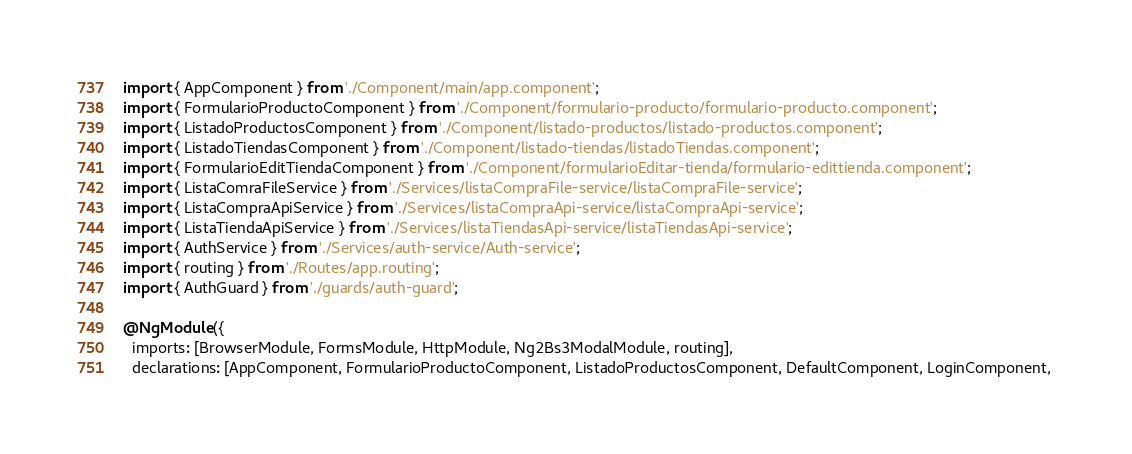Convert code to text. <code><loc_0><loc_0><loc_500><loc_500><_TypeScript_>import { AppComponent } from './Component/main/app.component';
import { FormularioProductoComponent } from './Component/formulario-producto/formulario-producto.component';
import { ListadoProductosComponent } from './Component/listado-productos/listado-productos.component';
import { ListadoTiendasComponent } from './Component/listado-tiendas/listadoTiendas.component';
import { FormularioEditTiendaComponent } from './Component/formularioEditar-tienda/formulario-edittienda.component';
import { ListaComraFileService } from './Services/listaCompraFile-service/listaCompraFile-service';
import { ListaCompraApiService } from './Services/listaCompraApi-service/listaCompraApi-service';
import { ListaTiendaApiService } from './Services/listaTiendasApi-service/listaTiendasApi-service';
import { AuthService } from './Services/auth-service/Auth-service';
import { routing } from './Routes/app.routing';
import { AuthGuard } from './guards/auth-guard';

@NgModule({
  imports: [BrowserModule, FormsModule, HttpModule, Ng2Bs3ModalModule, routing],
  declarations: [AppComponent, FormularioProductoComponent, ListadoProductosComponent, DefaultComponent, LoginComponent, </code> 